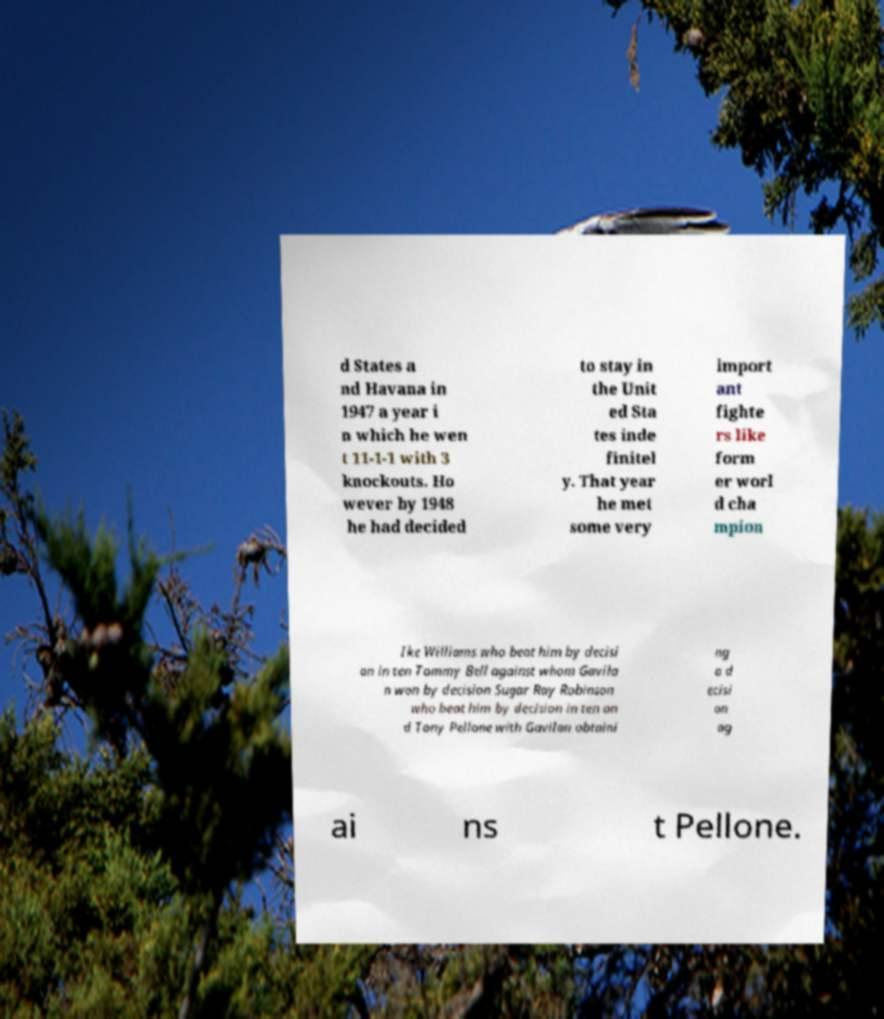Could you assist in decoding the text presented in this image and type it out clearly? d States a nd Havana in 1947 a year i n which he wen t 11-1-1 with 3 knockouts. Ho wever by 1948 he had decided to stay in the Unit ed Sta tes inde finitel y. That year he met some very import ant fighte rs like form er worl d cha mpion Ike Williams who beat him by decisi on in ten Tommy Bell against whom Gavila n won by decision Sugar Ray Robinson who beat him by decision in ten an d Tony Pellone with Gavilan obtaini ng a d ecisi on ag ai ns t Pellone. 